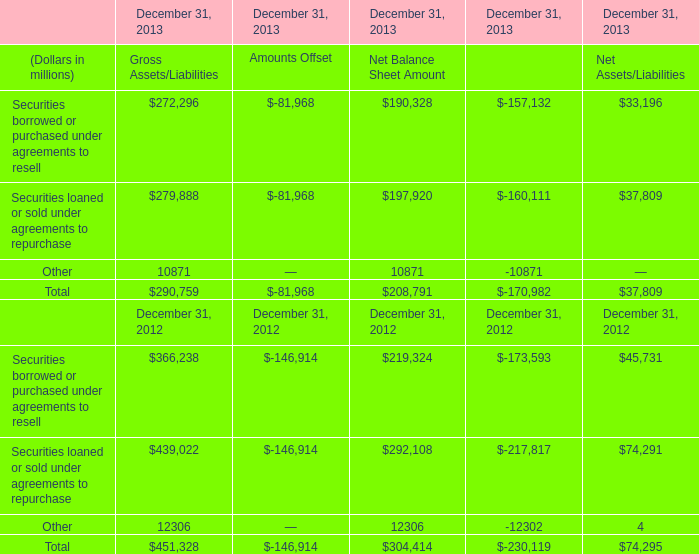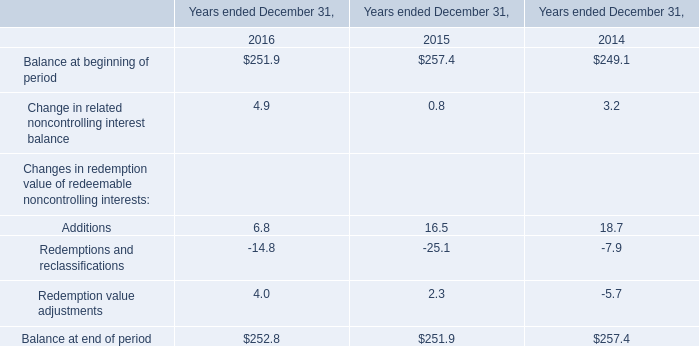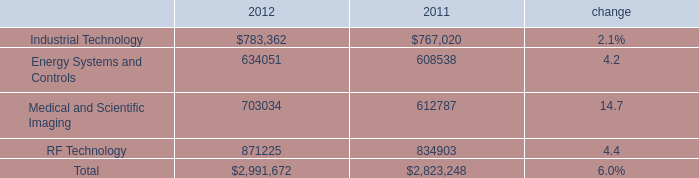What's the sum of Other of December 31, 2013 Net Balance Sheet Amount, and Medical and Scientific Imaging of 2011 ? 
Computations: (12306.0 + 612787.0)
Answer: 625093.0. 